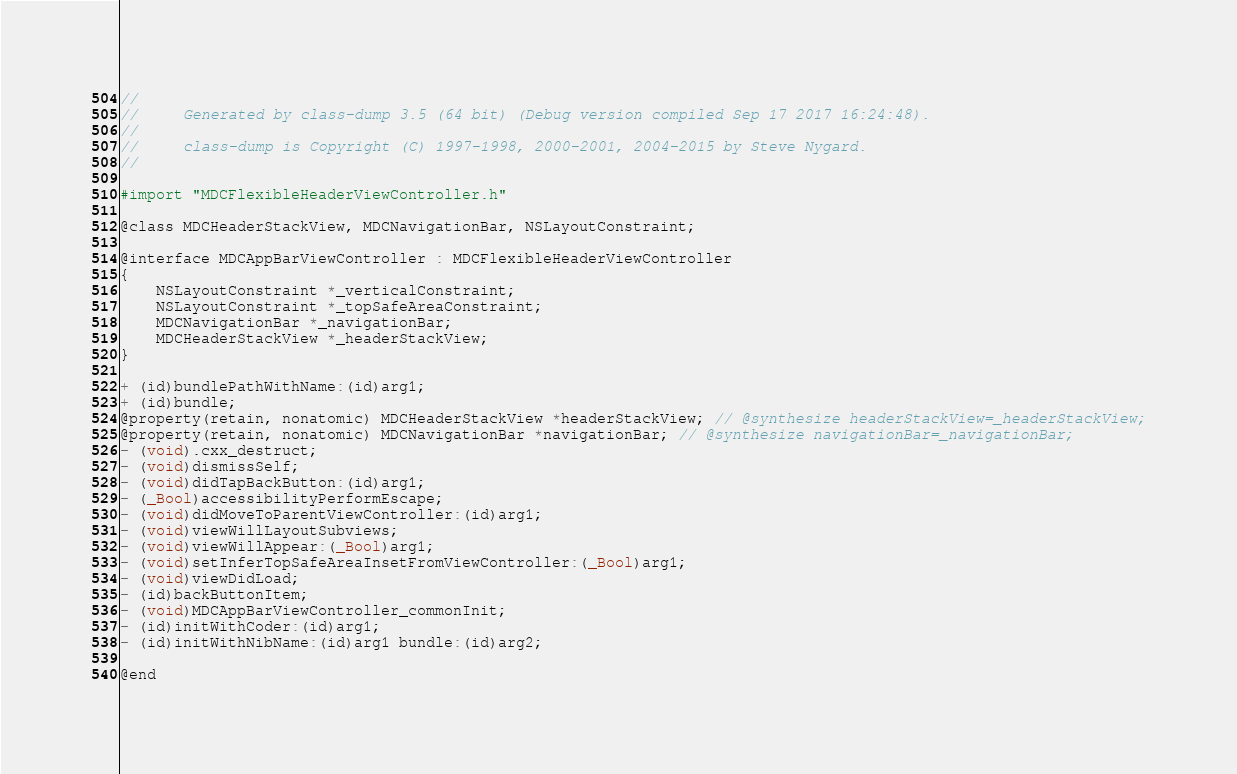Convert code to text. <code><loc_0><loc_0><loc_500><loc_500><_C_>//
//     Generated by class-dump 3.5 (64 bit) (Debug version compiled Sep 17 2017 16:24:48).
//
//     class-dump is Copyright (C) 1997-1998, 2000-2001, 2004-2015 by Steve Nygard.
//

#import "MDCFlexibleHeaderViewController.h"

@class MDCHeaderStackView, MDCNavigationBar, NSLayoutConstraint;

@interface MDCAppBarViewController : MDCFlexibleHeaderViewController
{
    NSLayoutConstraint *_verticalConstraint;
    NSLayoutConstraint *_topSafeAreaConstraint;
    MDCNavigationBar *_navigationBar;
    MDCHeaderStackView *_headerStackView;
}

+ (id)bundlePathWithName:(id)arg1;
+ (id)bundle;
@property(retain, nonatomic) MDCHeaderStackView *headerStackView; // @synthesize headerStackView=_headerStackView;
@property(retain, nonatomic) MDCNavigationBar *navigationBar; // @synthesize navigationBar=_navigationBar;
- (void).cxx_destruct;
- (void)dismissSelf;
- (void)didTapBackButton:(id)arg1;
- (_Bool)accessibilityPerformEscape;
- (void)didMoveToParentViewController:(id)arg1;
- (void)viewWillLayoutSubviews;
- (void)viewWillAppear:(_Bool)arg1;
- (void)setInferTopSafeAreaInsetFromViewController:(_Bool)arg1;
- (void)viewDidLoad;
- (id)backButtonItem;
- (void)MDCAppBarViewController_commonInit;
- (id)initWithCoder:(id)arg1;
- (id)initWithNibName:(id)arg1 bundle:(id)arg2;

@end

</code> 